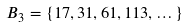<formula> <loc_0><loc_0><loc_500><loc_500>B _ { 3 } = \{ 1 7 , 3 1 , 6 1 , 1 1 3 , \dots \}</formula> 